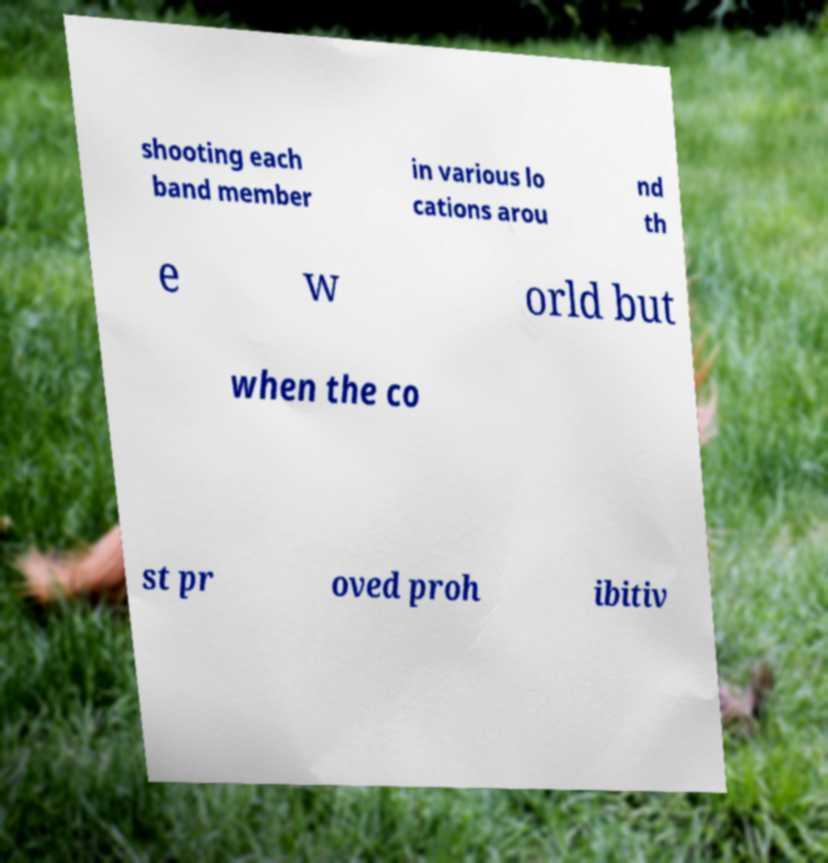What messages or text are displayed in this image? I need them in a readable, typed format. shooting each band member in various lo cations arou nd th e w orld but when the co st pr oved proh ibitiv 